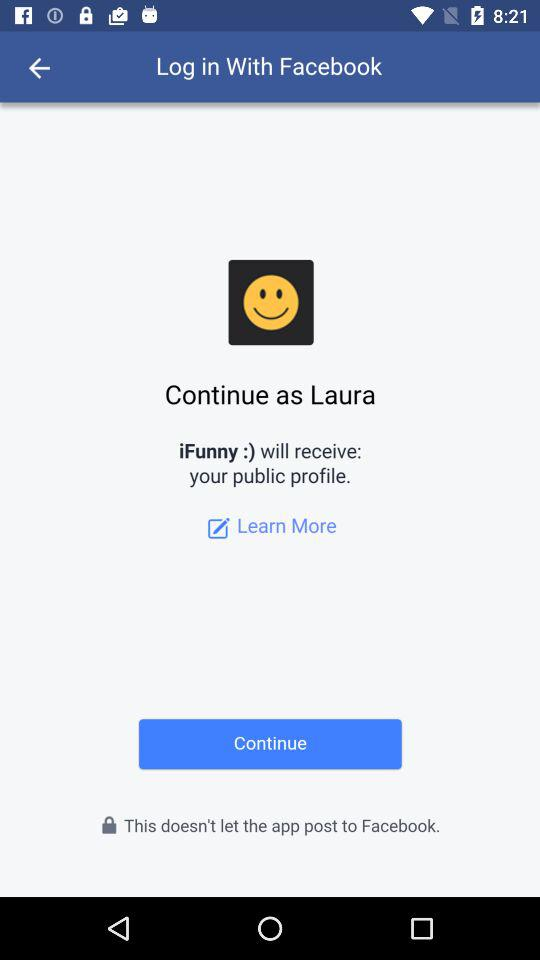What's the user name by which the application can be continued? The user name is Laura. 